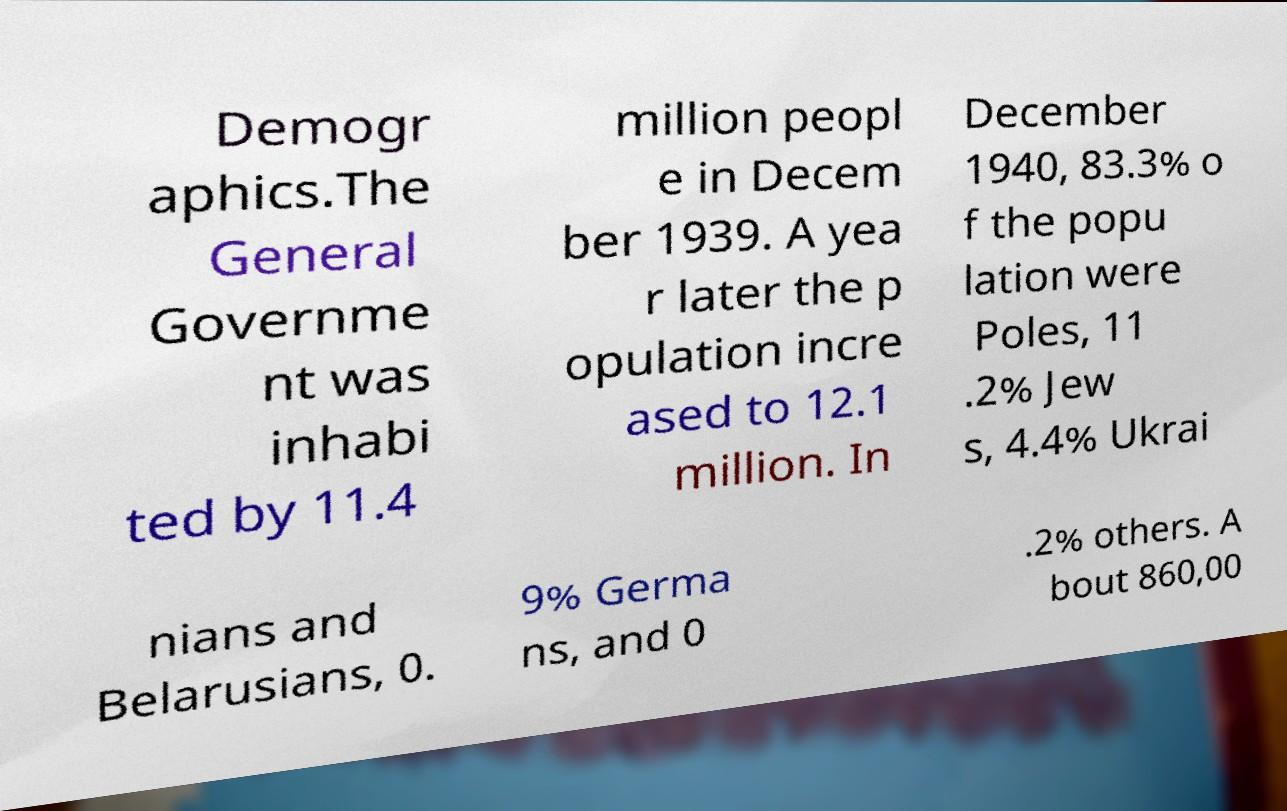There's text embedded in this image that I need extracted. Can you transcribe it verbatim? Demogr aphics.The General Governme nt was inhabi ted by 11.4 million peopl e in Decem ber 1939. A yea r later the p opulation incre ased to 12.1 million. In December 1940, 83.3% o f the popu lation were Poles, 11 .2% Jew s, 4.4% Ukrai nians and Belarusians, 0. 9% Germa ns, and 0 .2% others. A bout 860,00 